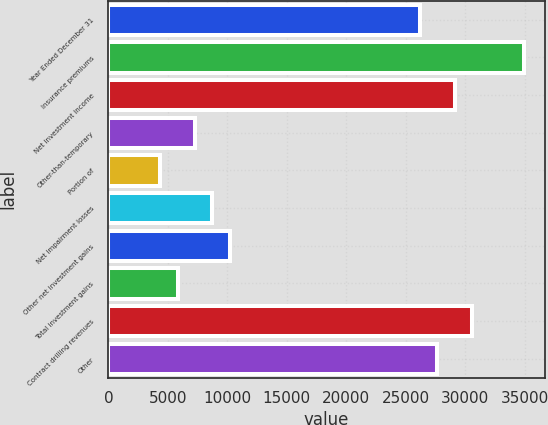Convert chart to OTSL. <chart><loc_0><loc_0><loc_500><loc_500><bar_chart><fcel>Year Ended December 31<fcel>Insurance premiums<fcel>Net investment income<fcel>Other-than-temporary<fcel>Portion of<fcel>Net impairment losses<fcel>Other net investment gains<fcel>Total investment gains<fcel>Contract drilling revenues<fcel>Other<nl><fcel>26193.4<fcel>34924.5<fcel>29103.8<fcel>7276.12<fcel>4365.78<fcel>8731.3<fcel>10186.5<fcel>5820.95<fcel>30558.9<fcel>27648.6<nl></chart> 